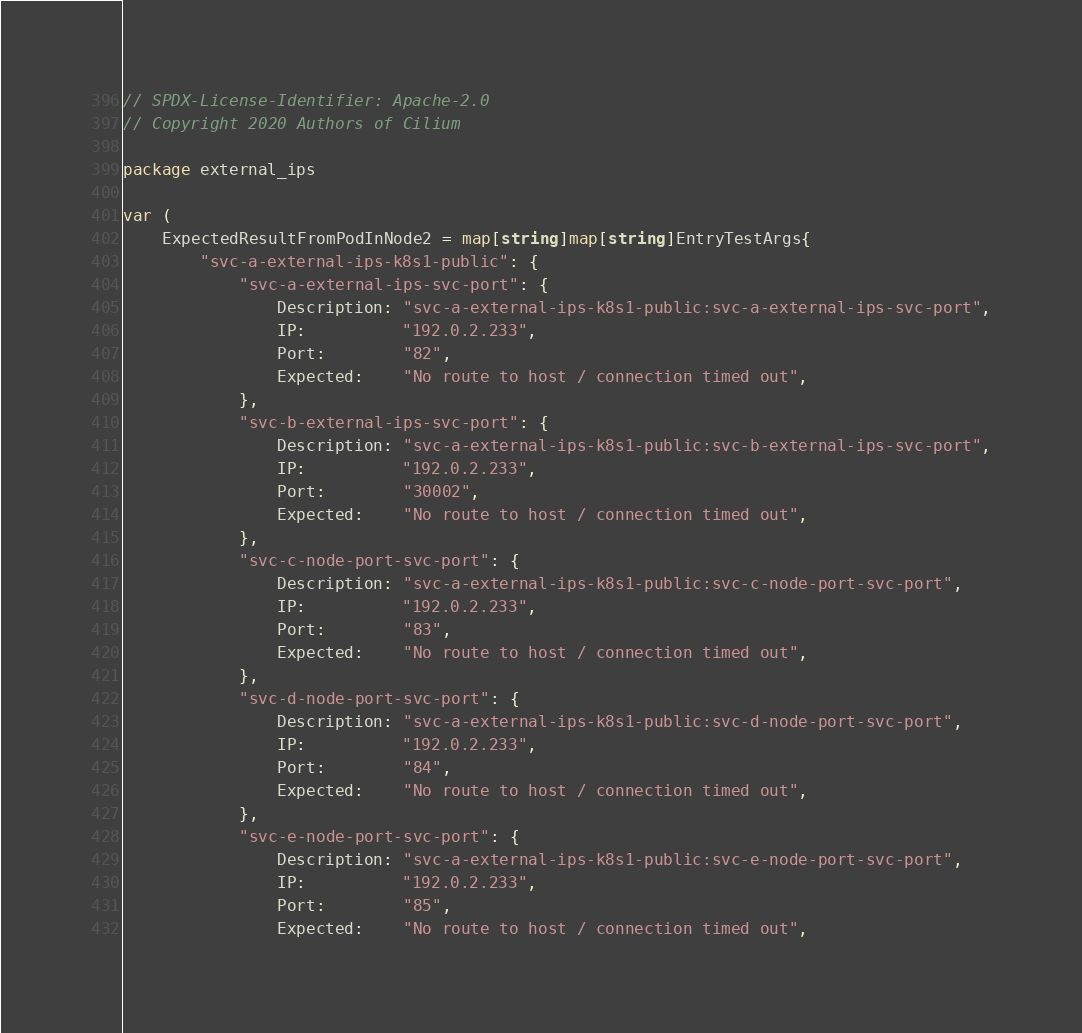Convert code to text. <code><loc_0><loc_0><loc_500><loc_500><_Go_>// SPDX-License-Identifier: Apache-2.0
// Copyright 2020 Authors of Cilium

package external_ips

var (
	ExpectedResultFromPodInNode2 = map[string]map[string]EntryTestArgs{
		"svc-a-external-ips-k8s1-public": {
			"svc-a-external-ips-svc-port": {
				Description: "svc-a-external-ips-k8s1-public:svc-a-external-ips-svc-port",
				IP:          "192.0.2.233",
				Port:        "82",
				Expected:    "No route to host / connection timed out",
			},
			"svc-b-external-ips-svc-port": {
				Description: "svc-a-external-ips-k8s1-public:svc-b-external-ips-svc-port",
				IP:          "192.0.2.233",
				Port:        "30002",
				Expected:    "No route to host / connection timed out",
			},
			"svc-c-node-port-svc-port": {
				Description: "svc-a-external-ips-k8s1-public:svc-c-node-port-svc-port",
				IP:          "192.0.2.233",
				Port:        "83",
				Expected:    "No route to host / connection timed out",
			},
			"svc-d-node-port-svc-port": {
				Description: "svc-a-external-ips-k8s1-public:svc-d-node-port-svc-port",
				IP:          "192.0.2.233",
				Port:        "84",
				Expected:    "No route to host / connection timed out",
			},
			"svc-e-node-port-svc-port": {
				Description: "svc-a-external-ips-k8s1-public:svc-e-node-port-svc-port",
				IP:          "192.0.2.233",
				Port:        "85",
				Expected:    "No route to host / connection timed out",</code> 